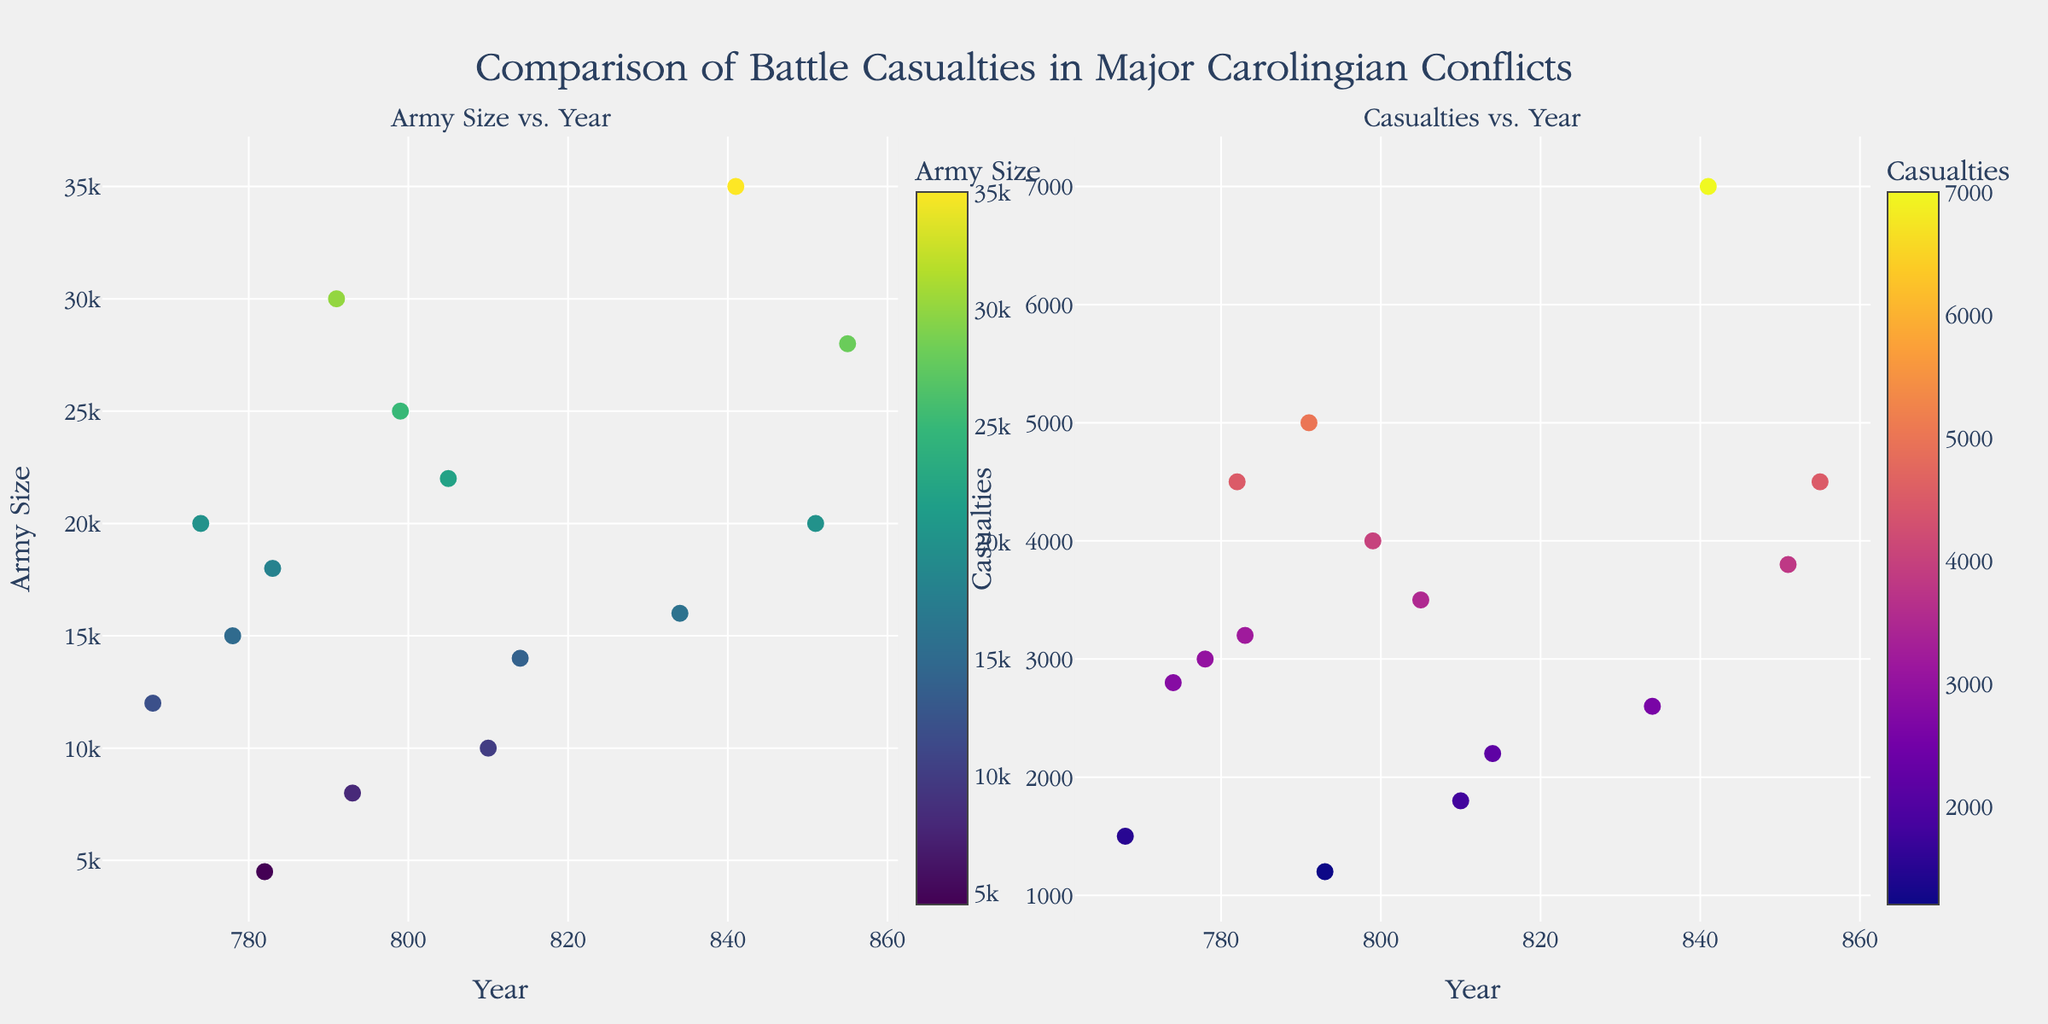What is the title of the plot? The title of the plot is displayed at the top center of the figure and reads "Comparison of Battle Casualties in Major Carolingian Conflicts."
Answer: Comparison of Battle Casualties in Major Carolingian Conflicts What are the x-axis labels for both subplots? The x-axis labels for both subplots are titled "Year," indicating that the horizontal axis in each subplot represents the year in which the battles occurred.
Answer: Year How many data points are shown in each subplot? Count the number of markers (dots) in each subplot. There are 15 data points in each subplot, matching each battle entry in the dataset.
Answer: 15 Which battle had the largest army size? The battle with the largest army size can be identified by hovering over the highest point on the y-axis of the left subplot, which represents the Army Size.
Answer: Battle of Fontenoy Which year had the lowest casualties and what was the battle associated with it? Hover over the lowest point on the y-axis of the right subplot labeled "Casualties" to find the year and corresponding battle.
Answer: 793, Battle of Rügen What is the average casualty count across all battles? Sum all the casualty counts: 1500 + 2800 + 3000 + 4500 + 3200 + 5000 + 1200 + 4000 + 3500 + 1800 + 2200 + 2600 + 7000 + 3800 + 4500 = 52,600. Divide by the number of battles (15): 52,600 / 15 = 3,506.67.
Answer: 3506.67 Compare the army size and casualties for the Battle of Roncevaux Pass and Battle of Detmold. Which battle had higher casualties and larger army size? Look for the data points corresponding to these battles by hovering over the markers in both subplots. The Battle of Roncevaux Pass had an army size of 15,000 and 3,000 casualties, whereas the Battle of Detmold had an army size of 18,000 and 3,200 casualties.
Answer: Battle of Detmold had higher casualties and larger army size Which battle had the highest casualty count and in what year did it occur? Identify the highest point on the y-axis of the right subplot labeled "Casualties." Hover over this point to find the year and battle.
Answer: Battle of Fontenoy, 841 